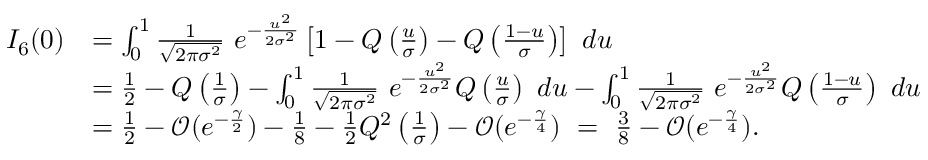<formula> <loc_0><loc_0><loc_500><loc_500>\begin{array} { r l } { I _ { 6 } ( 0 ) } & { = \int _ { 0 } ^ { 1 } \frac { 1 } { \sqrt { 2 \pi \sigma ^ { 2 } } } e ^ { - \frac { u ^ { 2 } } { 2 \sigma ^ { 2 } } } \left [ 1 - Q \left ( \frac { u } { \sigma } \right ) - Q \left ( \frac { 1 - u } { \sigma } \right ) \right ] d u } \\ & { = \frac { 1 } { 2 } - Q \left ( \frac { 1 } { \sigma } \right ) - \int _ { 0 } ^ { 1 } \frac { 1 } { \sqrt { 2 \pi \sigma ^ { 2 } } } e ^ { - \frac { u ^ { 2 } } { 2 \sigma ^ { 2 } } } Q \left ( \frac { u } { \sigma } \right ) d u - \int _ { 0 } ^ { 1 } \frac { 1 } { \sqrt { 2 \pi \sigma ^ { 2 } } } e ^ { - \frac { u ^ { 2 } } { 2 \sigma ^ { 2 } } } Q \left ( \frac { 1 - u } { \sigma } \right ) d u } \\ & { = \frac { 1 } { 2 } - \mathcal { O } ( e ^ { - \frac { \gamma } { 2 } } ) - \frac { 1 } { 8 } - \frac { 1 } { 2 } Q ^ { 2 } \left ( \frac { 1 } { \sigma } \right ) - \mathcal { O } ( e ^ { - \frac { \gamma } { 4 } } ) = \frac { 3 } { 8 } - \mathcal { O } ( e ^ { - \frac { \gamma } { 4 } } ) . } \end{array}</formula> 